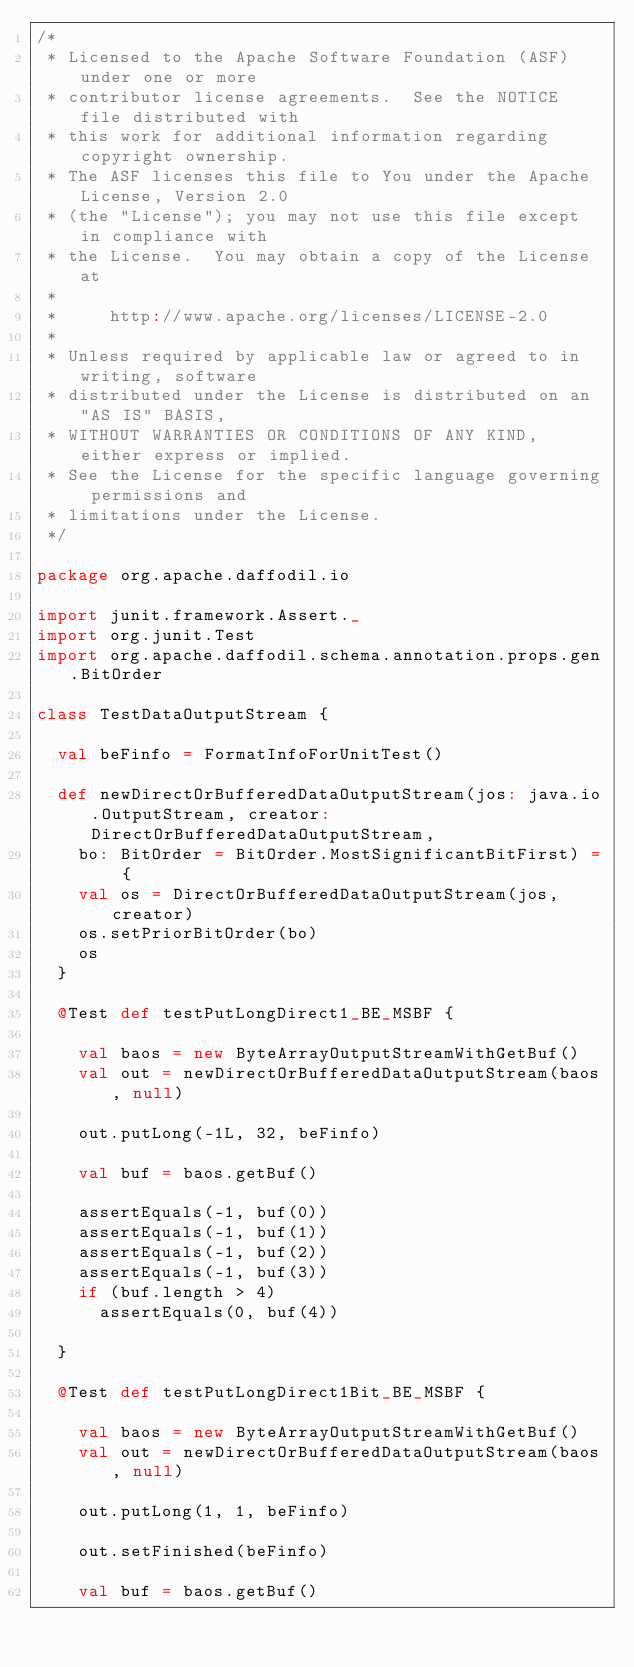Convert code to text. <code><loc_0><loc_0><loc_500><loc_500><_Scala_>/*
 * Licensed to the Apache Software Foundation (ASF) under one or more
 * contributor license agreements.  See the NOTICE file distributed with
 * this work for additional information regarding copyright ownership.
 * The ASF licenses this file to You under the Apache License, Version 2.0
 * (the "License"); you may not use this file except in compliance with
 * the License.  You may obtain a copy of the License at
 *
 *     http://www.apache.org/licenses/LICENSE-2.0
 *
 * Unless required by applicable law or agreed to in writing, software
 * distributed under the License is distributed on an "AS IS" BASIS,
 * WITHOUT WARRANTIES OR CONDITIONS OF ANY KIND, either express or implied.
 * See the License for the specific language governing permissions and
 * limitations under the License.
 */

package org.apache.daffodil.io

import junit.framework.Assert._
import org.junit.Test
import org.apache.daffodil.schema.annotation.props.gen.BitOrder

class TestDataOutputStream {

  val beFinfo = FormatInfoForUnitTest()

  def newDirectOrBufferedDataOutputStream(jos: java.io.OutputStream, creator: DirectOrBufferedDataOutputStream,
    bo: BitOrder = BitOrder.MostSignificantBitFirst) = {
    val os = DirectOrBufferedDataOutputStream(jos, creator)
    os.setPriorBitOrder(bo)
    os
  }

  @Test def testPutLongDirect1_BE_MSBF {

    val baos = new ByteArrayOutputStreamWithGetBuf()
    val out = newDirectOrBufferedDataOutputStream(baos, null)

    out.putLong(-1L, 32, beFinfo)

    val buf = baos.getBuf()

    assertEquals(-1, buf(0))
    assertEquals(-1, buf(1))
    assertEquals(-1, buf(2))
    assertEquals(-1, buf(3))
    if (buf.length > 4)
      assertEquals(0, buf(4))

  }

  @Test def testPutLongDirect1Bit_BE_MSBF {

    val baos = new ByteArrayOutputStreamWithGetBuf()
    val out = newDirectOrBufferedDataOutputStream(baos, null)

    out.putLong(1, 1, beFinfo)

    out.setFinished(beFinfo)

    val buf = baos.getBuf()
</code> 